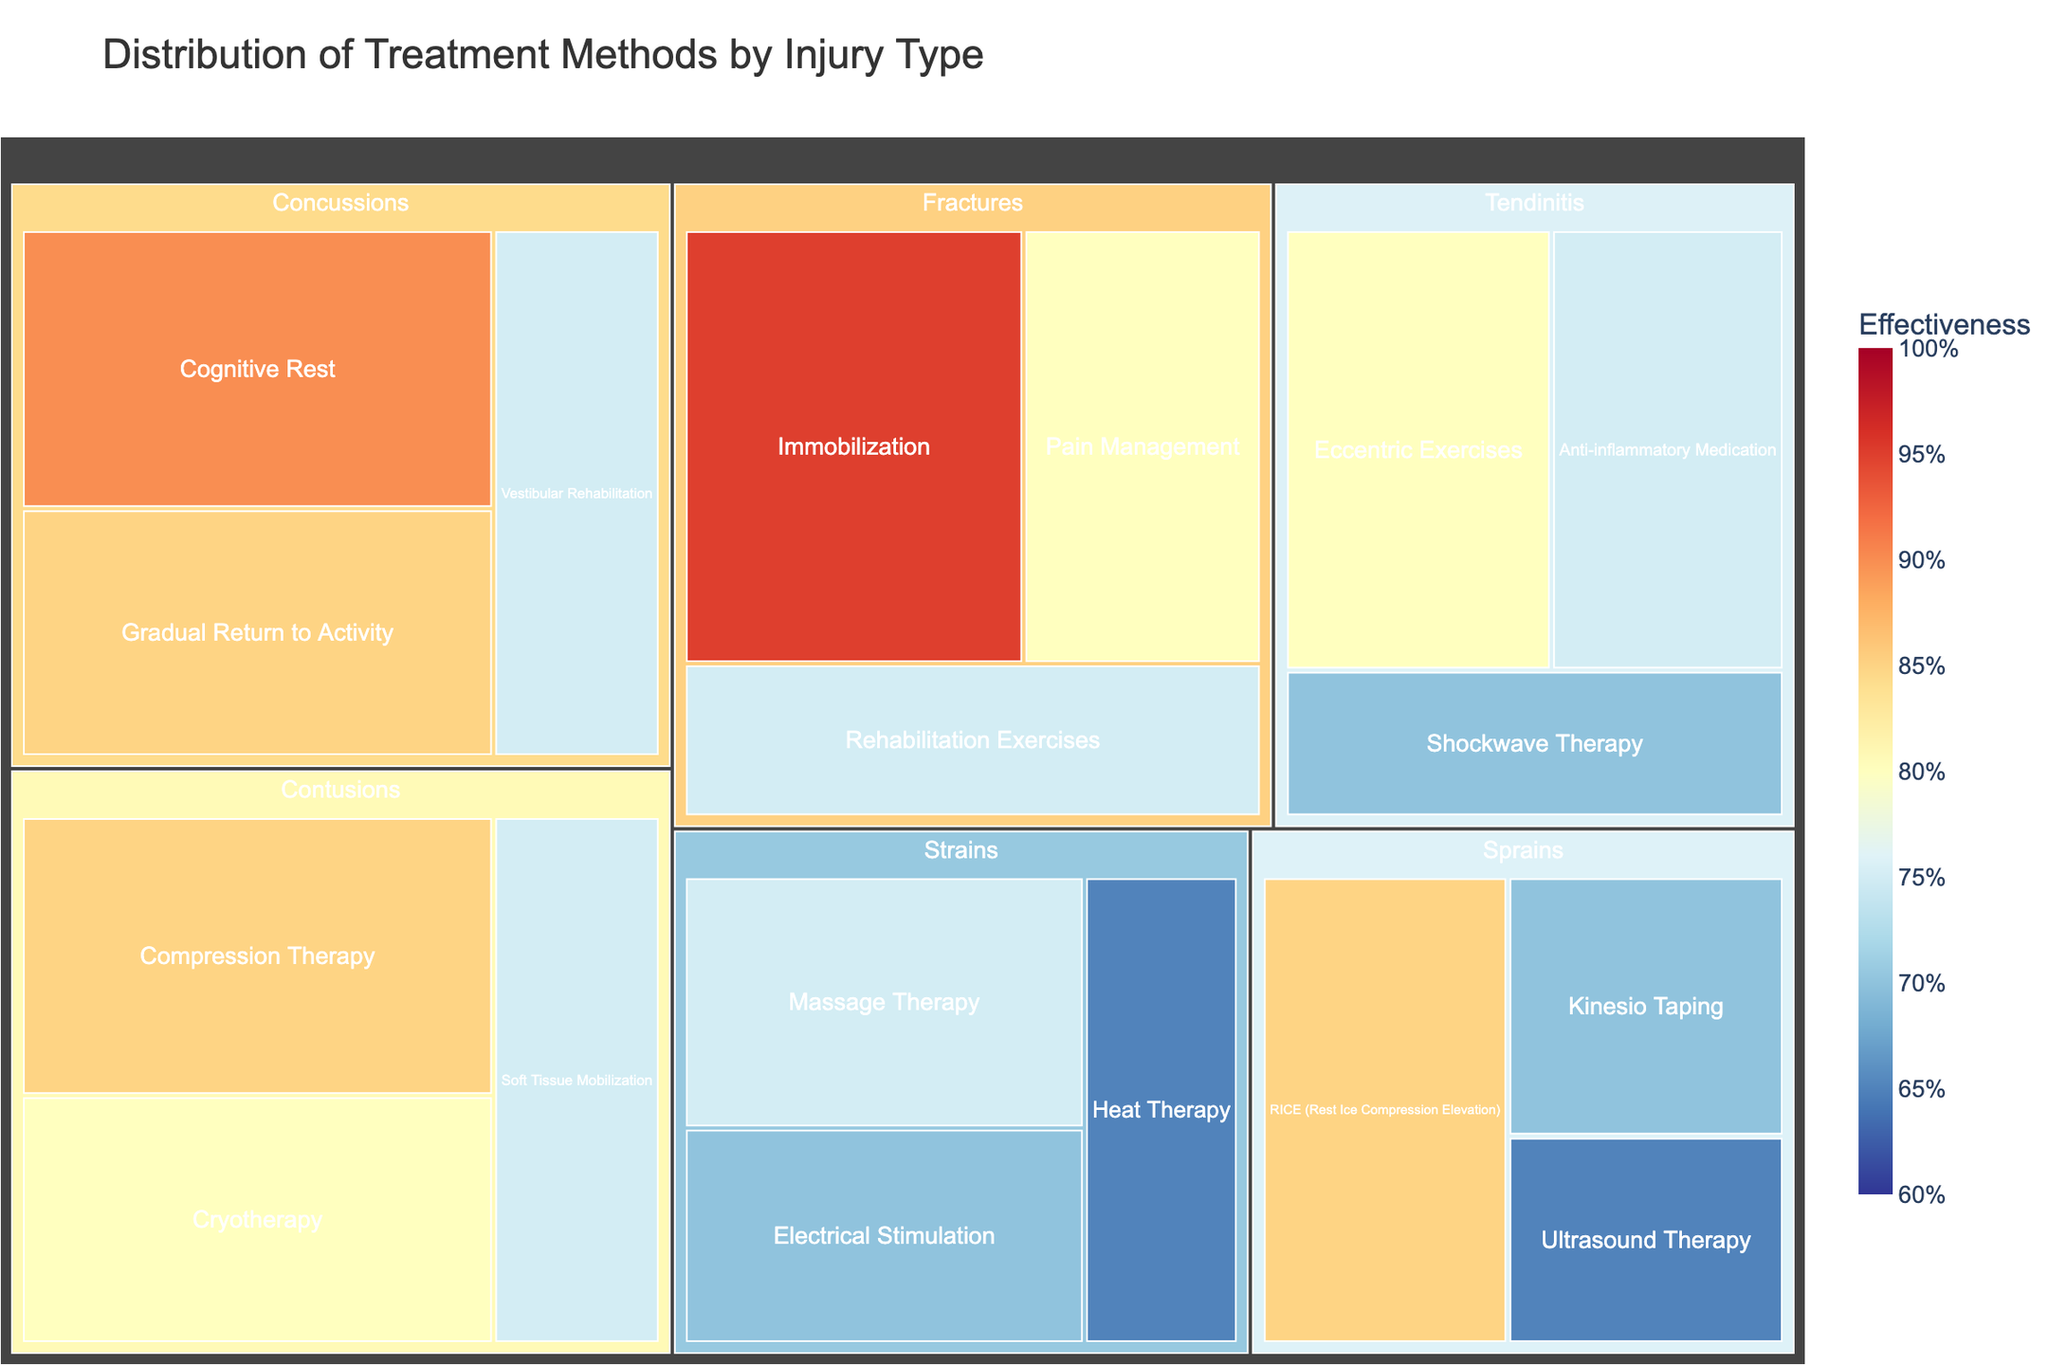Which injury type has the highest effectiveness in treatment methods? Examine the colors in the figure for each injury type. The darkest blue shade indicates the highest effectiveness. Look for the injury type associated with this color.
Answer: Fractures What is the most frequently used treatment method for sprains, and its effectiveness? Check the size of the blocks within the Sprains category. The largest block represents the most frequently used method. Hover over this block to check its Usage Frequency and Effectiveness.
Answer: RICE (40 times; 85%) What is the difference in usage frequency between Cognitive Rest and Vestibular Rehabilitation for concussions? Identify the blocks representing Cognitive Rest and Vestibular Rehabilitation under Concussions. Compare their Usage Frequency values and calculate the difference (45 - 30).
Answer: 15 Which treatment method for contusions has the highest effectiveness, and what is the value? Look at the color intensity within the Contusions category. The darkest, most saturated block will display the highest effectiveness score.
Answer: Compression Therapy (85%) How many treatment methods are used for fractures? Count the number of blocks under the Fractures category.
Answer: 3 What is the average effectiveness of treatment methods used for tendinitis? Locate the blocks under Tendinitis and note their effectiveness values (80, 75, 70). Calculate the average by summing these values and dividing by the number of methods. (80 + 75 + 70) / 3 = 75
Answer: 75 Which treatment method for strains is used less frequently than 30 times? Identify the blocks under Strains and compare their Usage Frequency values to 30. Find the block(s) with values less than 30.
Answer: Heat Therapy (25 times) Compare the effectiveness of Ultrasound Therapy for sprains and Shockwave Therapy for tendinitis. Which one is more effective? Locate the blocks for Ultrasound Therapy under Sprains and Shockwave Therapy under Tendinitis. Compare their effectiveness values (65 vs. 70).
Answer: Shockwave Therapy (70%) How does the usability of Gradual Return to Activity for concussions compare to Massage Therapy for strains? Check both blocks under their respective categories. Compare their Usage Frequency values (40 vs. 35).
Answer: Gradual Return to Activity is used more (40 vs. 35) Which injury type has the least effective treatment method? Identify the blocks with the lightest color, indicating the lowest effectiveness values. Note the injury type this block falls under.
Answer: Sprains (Ultrasound Therapy - 65%) 